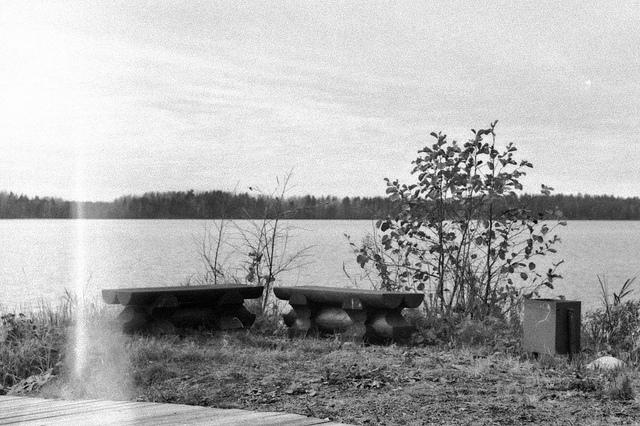How many benches are there?
Be succinct. 2. Are the plants dying?
Keep it brief. No. Is there a breeze?
Give a very brief answer. Yes. Why is everything all wet?
Short answer required. Lake. Is there a dog in the picture?
Quick response, please. No. 